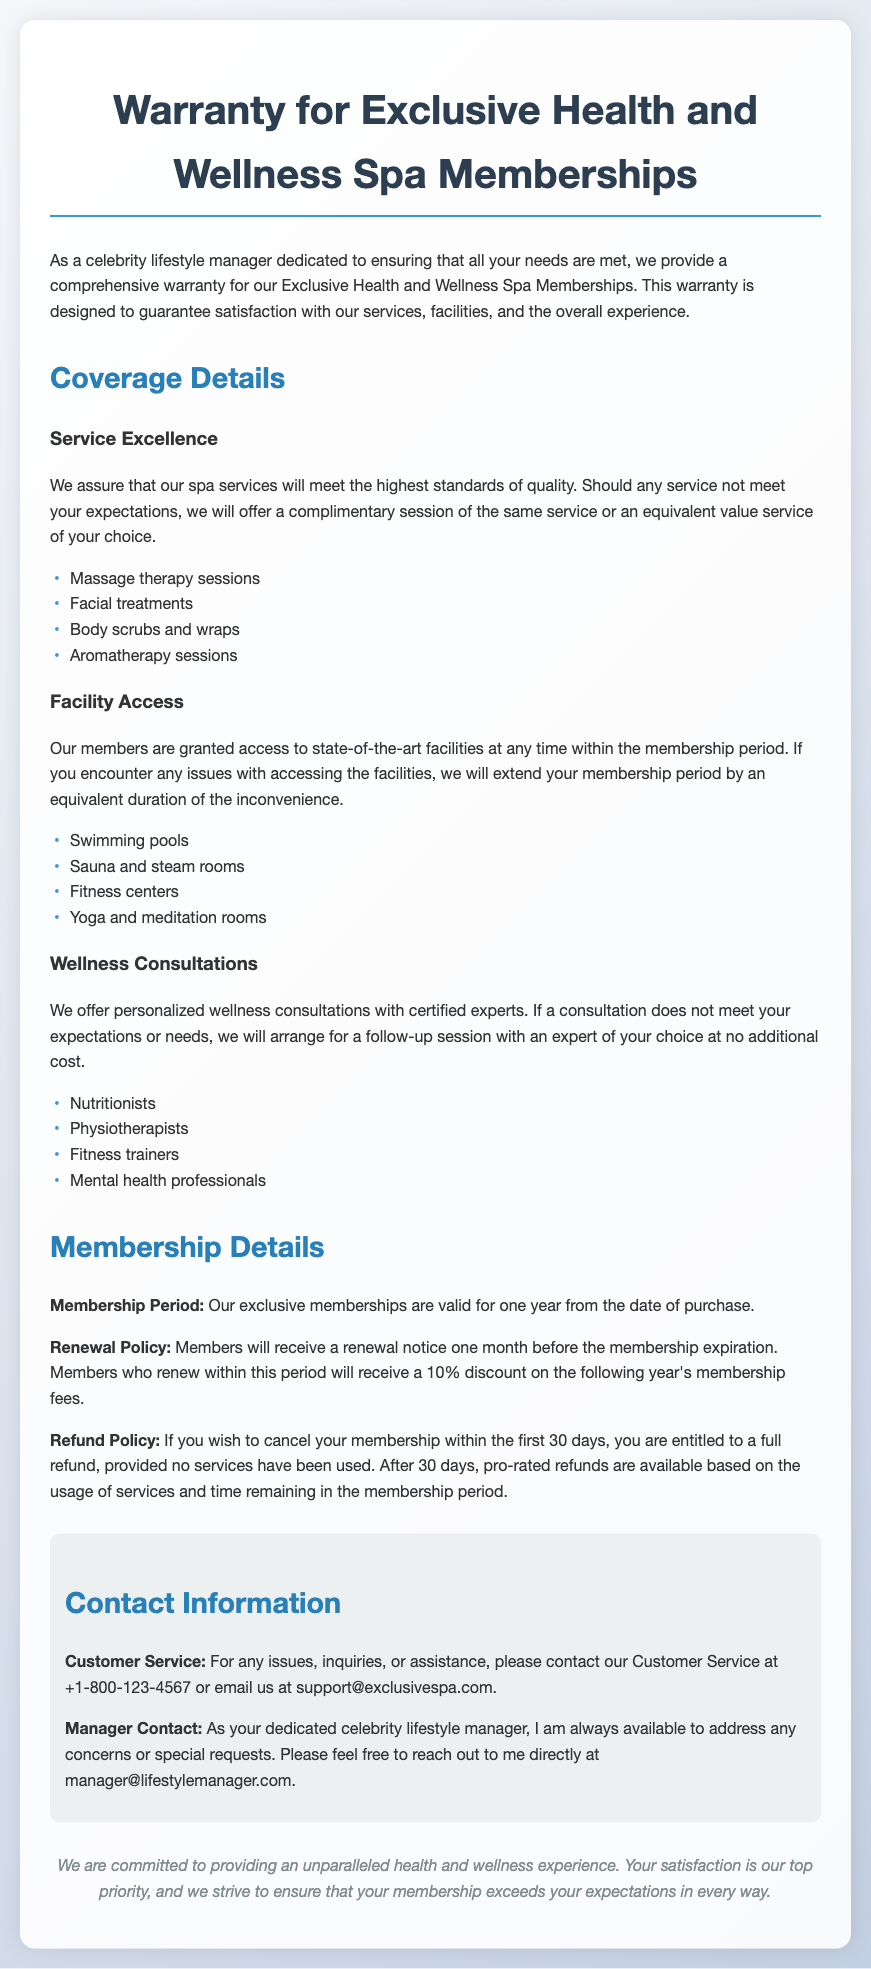What is the warranty designed to guarantee? The warranty is designed to guarantee satisfaction with services, facilities, and the overall experience.
Answer: Satisfaction How long is the membership period? The membership period is valid for one year from the date of purchase.
Answer: One year What discount do members receive upon renewal? Members who renew within the specified period receive a 10% discount on the following year's membership fees.
Answer: 10% What happens if a service does not meet expectations? If any service does not meet expectations, a complimentary session of the same service or an equivalent value service will be offered.
Answer: Complimentary session What facilities are included in the membership? Members have access to swimming pools, sauna and steam rooms, fitness centers, and yoga and meditation rooms.
Answer: Swimming pools, sauna and steam rooms, fitness centers, yoga and meditation rooms What is the refund policy during the first 30 days? If membership is canceled within the first 30 days, the member is entitled to a full refund, provided no services have been used.
Answer: Full refund How can members contact customer service? Members can contact customer service at +1-800-123-4567 or email support@exclusivespa.com.
Answer: +1-800-123-4567 What kind of consultations do members receive? Members receive personalized wellness consultations with certified experts such as nutritionists, physiotherapists, and fitness trainers.
Answer: Personalized wellness consultations 